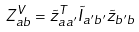<formula> <loc_0><loc_0><loc_500><loc_500>Z ^ { V } _ { a b } = \tilde { z } ^ { T } _ { a a ^ { \prime } } \tilde { I } _ { a ^ { \prime } b ^ { \prime } } \tilde { z } _ { b ^ { \prime } b }</formula> 